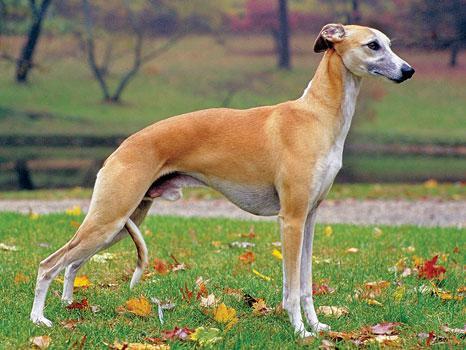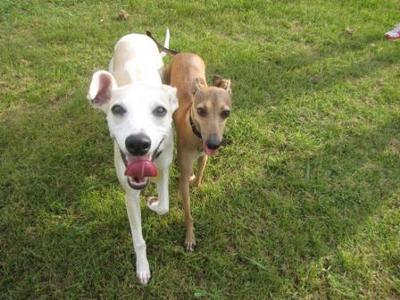The first image is the image on the left, the second image is the image on the right. Given the left and right images, does the statement "The right image contains at least two dogs." hold true? Answer yes or no. Yes. The first image is the image on the left, the second image is the image on the right. Given the left and right images, does the statement "At least one image shows a tan dog with a white chest standing on grass, facing leftward." hold true? Answer yes or no. No. 